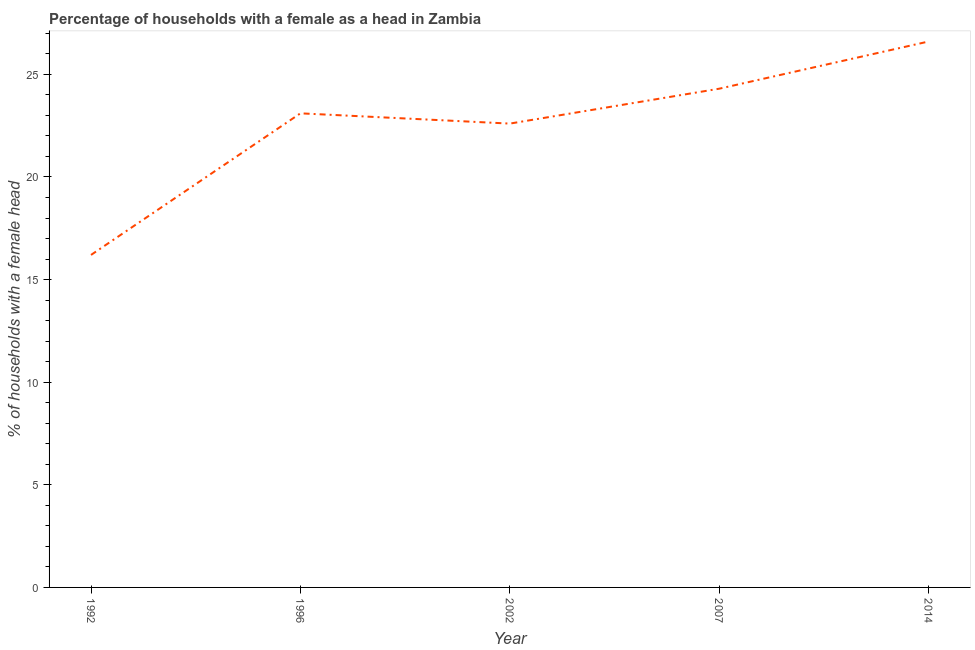What is the number of female supervised households in 2007?
Your answer should be very brief. 24.3. Across all years, what is the maximum number of female supervised households?
Your answer should be compact. 26.6. Across all years, what is the minimum number of female supervised households?
Keep it short and to the point. 16.2. In which year was the number of female supervised households minimum?
Offer a terse response. 1992. What is the sum of the number of female supervised households?
Your response must be concise. 112.8. What is the difference between the number of female supervised households in 1992 and 2014?
Your answer should be compact. -10.4. What is the average number of female supervised households per year?
Ensure brevity in your answer.  22.56. What is the median number of female supervised households?
Provide a succinct answer. 23.1. What is the ratio of the number of female supervised households in 2007 to that in 2014?
Your response must be concise. 0.91. Is the number of female supervised households in 1992 less than that in 2002?
Your answer should be compact. Yes. What is the difference between the highest and the second highest number of female supervised households?
Offer a very short reply. 2.3. Is the sum of the number of female supervised households in 1992 and 2002 greater than the maximum number of female supervised households across all years?
Your answer should be compact. Yes. What is the difference between the highest and the lowest number of female supervised households?
Offer a terse response. 10.4. In how many years, is the number of female supervised households greater than the average number of female supervised households taken over all years?
Provide a short and direct response. 4. How many years are there in the graph?
Provide a short and direct response. 5. What is the title of the graph?
Offer a terse response. Percentage of households with a female as a head in Zambia. What is the label or title of the Y-axis?
Provide a short and direct response. % of households with a female head. What is the % of households with a female head of 1992?
Ensure brevity in your answer.  16.2. What is the % of households with a female head in 1996?
Ensure brevity in your answer.  23.1. What is the % of households with a female head in 2002?
Your answer should be compact. 22.6. What is the % of households with a female head in 2007?
Keep it short and to the point. 24.3. What is the % of households with a female head in 2014?
Keep it short and to the point. 26.6. What is the difference between the % of households with a female head in 1992 and 2002?
Give a very brief answer. -6.4. What is the difference between the % of households with a female head in 1992 and 2007?
Your response must be concise. -8.1. What is the difference between the % of households with a female head in 1992 and 2014?
Offer a very short reply. -10.4. What is the difference between the % of households with a female head in 1996 and 2007?
Give a very brief answer. -1.2. What is the difference between the % of households with a female head in 1996 and 2014?
Ensure brevity in your answer.  -3.5. What is the difference between the % of households with a female head in 2002 and 2007?
Make the answer very short. -1.7. What is the difference between the % of households with a female head in 2002 and 2014?
Provide a succinct answer. -4. What is the difference between the % of households with a female head in 2007 and 2014?
Provide a short and direct response. -2.3. What is the ratio of the % of households with a female head in 1992 to that in 1996?
Provide a succinct answer. 0.7. What is the ratio of the % of households with a female head in 1992 to that in 2002?
Give a very brief answer. 0.72. What is the ratio of the % of households with a female head in 1992 to that in 2007?
Offer a very short reply. 0.67. What is the ratio of the % of households with a female head in 1992 to that in 2014?
Give a very brief answer. 0.61. What is the ratio of the % of households with a female head in 1996 to that in 2002?
Keep it short and to the point. 1.02. What is the ratio of the % of households with a female head in 1996 to that in 2007?
Offer a terse response. 0.95. What is the ratio of the % of households with a female head in 1996 to that in 2014?
Make the answer very short. 0.87. What is the ratio of the % of households with a female head in 2002 to that in 2007?
Provide a short and direct response. 0.93. What is the ratio of the % of households with a female head in 2002 to that in 2014?
Provide a succinct answer. 0.85. What is the ratio of the % of households with a female head in 2007 to that in 2014?
Ensure brevity in your answer.  0.91. 